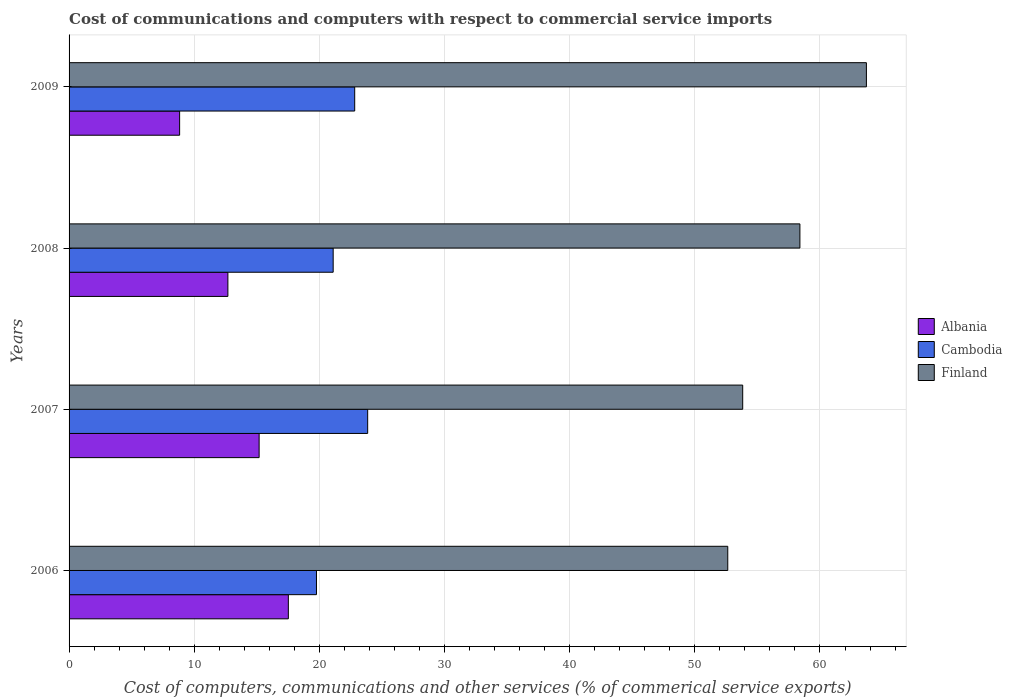How many different coloured bars are there?
Offer a very short reply. 3. How many groups of bars are there?
Offer a terse response. 4. Are the number of bars per tick equal to the number of legend labels?
Ensure brevity in your answer.  Yes. Are the number of bars on each tick of the Y-axis equal?
Your answer should be compact. Yes. What is the label of the 4th group of bars from the top?
Provide a short and direct response. 2006. What is the cost of communications and computers in Cambodia in 2008?
Give a very brief answer. 21.1. Across all years, what is the maximum cost of communications and computers in Albania?
Your answer should be very brief. 17.52. Across all years, what is the minimum cost of communications and computers in Cambodia?
Offer a terse response. 19.77. In which year was the cost of communications and computers in Cambodia minimum?
Offer a very short reply. 2006. What is the total cost of communications and computers in Finland in the graph?
Offer a very short reply. 228.56. What is the difference between the cost of communications and computers in Cambodia in 2006 and that in 2009?
Your answer should be very brief. -3.05. What is the difference between the cost of communications and computers in Cambodia in 2008 and the cost of communications and computers in Finland in 2007?
Make the answer very short. -32.72. What is the average cost of communications and computers in Cambodia per year?
Your response must be concise. 21.89. In the year 2009, what is the difference between the cost of communications and computers in Cambodia and cost of communications and computers in Albania?
Give a very brief answer. 13.99. What is the ratio of the cost of communications and computers in Finland in 2007 to that in 2008?
Your answer should be compact. 0.92. Is the cost of communications and computers in Cambodia in 2006 less than that in 2009?
Provide a succinct answer. Yes. What is the difference between the highest and the second highest cost of communications and computers in Finland?
Ensure brevity in your answer.  5.31. What is the difference between the highest and the lowest cost of communications and computers in Finland?
Provide a succinct answer. 11.08. What does the 2nd bar from the top in 2007 represents?
Your answer should be very brief. Cambodia. What does the 3rd bar from the bottom in 2008 represents?
Keep it short and to the point. Finland. Is it the case that in every year, the sum of the cost of communications and computers in Albania and cost of communications and computers in Finland is greater than the cost of communications and computers in Cambodia?
Offer a very short reply. Yes. How many bars are there?
Offer a terse response. 12. Are all the bars in the graph horizontal?
Your response must be concise. Yes. How many years are there in the graph?
Provide a succinct answer. 4. What is the difference between two consecutive major ticks on the X-axis?
Your response must be concise. 10. What is the title of the graph?
Give a very brief answer. Cost of communications and computers with respect to commercial service imports. Does "Fragile and conflict affected situations" appear as one of the legend labels in the graph?
Give a very brief answer. No. What is the label or title of the X-axis?
Offer a terse response. Cost of computers, communications and other services (% of commerical service exports). What is the label or title of the Y-axis?
Ensure brevity in your answer.  Years. What is the Cost of computers, communications and other services (% of commerical service exports) in Albania in 2006?
Provide a short and direct response. 17.52. What is the Cost of computers, communications and other services (% of commerical service exports) in Cambodia in 2006?
Offer a very short reply. 19.77. What is the Cost of computers, communications and other services (% of commerical service exports) of Finland in 2006?
Your answer should be very brief. 52.63. What is the Cost of computers, communications and other services (% of commerical service exports) in Albania in 2007?
Make the answer very short. 15.19. What is the Cost of computers, communications and other services (% of commerical service exports) of Cambodia in 2007?
Ensure brevity in your answer.  23.86. What is the Cost of computers, communications and other services (% of commerical service exports) in Finland in 2007?
Offer a very short reply. 53.83. What is the Cost of computers, communications and other services (% of commerical service exports) in Albania in 2008?
Provide a succinct answer. 12.69. What is the Cost of computers, communications and other services (% of commerical service exports) in Cambodia in 2008?
Your response must be concise. 21.1. What is the Cost of computers, communications and other services (% of commerical service exports) in Finland in 2008?
Give a very brief answer. 58.4. What is the Cost of computers, communications and other services (% of commerical service exports) in Albania in 2009?
Keep it short and to the point. 8.83. What is the Cost of computers, communications and other services (% of commerical service exports) in Cambodia in 2009?
Provide a succinct answer. 22.82. What is the Cost of computers, communications and other services (% of commerical service exports) of Finland in 2009?
Your answer should be very brief. 63.71. Across all years, what is the maximum Cost of computers, communications and other services (% of commerical service exports) in Albania?
Give a very brief answer. 17.52. Across all years, what is the maximum Cost of computers, communications and other services (% of commerical service exports) of Cambodia?
Keep it short and to the point. 23.86. Across all years, what is the maximum Cost of computers, communications and other services (% of commerical service exports) in Finland?
Your answer should be compact. 63.71. Across all years, what is the minimum Cost of computers, communications and other services (% of commerical service exports) of Albania?
Provide a short and direct response. 8.83. Across all years, what is the minimum Cost of computers, communications and other services (% of commerical service exports) in Cambodia?
Offer a very short reply. 19.77. Across all years, what is the minimum Cost of computers, communications and other services (% of commerical service exports) in Finland?
Your response must be concise. 52.63. What is the total Cost of computers, communications and other services (% of commerical service exports) in Albania in the graph?
Your response must be concise. 54.23. What is the total Cost of computers, communications and other services (% of commerical service exports) of Cambodia in the graph?
Ensure brevity in your answer.  87.55. What is the total Cost of computers, communications and other services (% of commerical service exports) of Finland in the graph?
Offer a terse response. 228.56. What is the difference between the Cost of computers, communications and other services (% of commerical service exports) of Albania in 2006 and that in 2007?
Ensure brevity in your answer.  2.33. What is the difference between the Cost of computers, communications and other services (% of commerical service exports) of Cambodia in 2006 and that in 2007?
Give a very brief answer. -4.09. What is the difference between the Cost of computers, communications and other services (% of commerical service exports) of Finland in 2006 and that in 2007?
Your response must be concise. -1.19. What is the difference between the Cost of computers, communications and other services (% of commerical service exports) in Albania in 2006 and that in 2008?
Keep it short and to the point. 4.83. What is the difference between the Cost of computers, communications and other services (% of commerical service exports) of Cambodia in 2006 and that in 2008?
Provide a succinct answer. -1.33. What is the difference between the Cost of computers, communications and other services (% of commerical service exports) in Finland in 2006 and that in 2008?
Ensure brevity in your answer.  -5.76. What is the difference between the Cost of computers, communications and other services (% of commerical service exports) of Albania in 2006 and that in 2009?
Your answer should be very brief. 8.69. What is the difference between the Cost of computers, communications and other services (% of commerical service exports) in Cambodia in 2006 and that in 2009?
Give a very brief answer. -3.05. What is the difference between the Cost of computers, communications and other services (% of commerical service exports) of Finland in 2006 and that in 2009?
Your response must be concise. -11.08. What is the difference between the Cost of computers, communications and other services (% of commerical service exports) in Albania in 2007 and that in 2008?
Keep it short and to the point. 2.5. What is the difference between the Cost of computers, communications and other services (% of commerical service exports) of Cambodia in 2007 and that in 2008?
Give a very brief answer. 2.76. What is the difference between the Cost of computers, communications and other services (% of commerical service exports) in Finland in 2007 and that in 2008?
Provide a succinct answer. -4.57. What is the difference between the Cost of computers, communications and other services (% of commerical service exports) in Albania in 2007 and that in 2009?
Provide a succinct answer. 6.35. What is the difference between the Cost of computers, communications and other services (% of commerical service exports) of Cambodia in 2007 and that in 2009?
Offer a terse response. 1.04. What is the difference between the Cost of computers, communications and other services (% of commerical service exports) in Finland in 2007 and that in 2009?
Your answer should be compact. -9.88. What is the difference between the Cost of computers, communications and other services (% of commerical service exports) in Albania in 2008 and that in 2009?
Keep it short and to the point. 3.86. What is the difference between the Cost of computers, communications and other services (% of commerical service exports) of Cambodia in 2008 and that in 2009?
Your response must be concise. -1.72. What is the difference between the Cost of computers, communications and other services (% of commerical service exports) in Finland in 2008 and that in 2009?
Ensure brevity in your answer.  -5.31. What is the difference between the Cost of computers, communications and other services (% of commerical service exports) in Albania in 2006 and the Cost of computers, communications and other services (% of commerical service exports) in Cambodia in 2007?
Keep it short and to the point. -6.34. What is the difference between the Cost of computers, communications and other services (% of commerical service exports) in Albania in 2006 and the Cost of computers, communications and other services (% of commerical service exports) in Finland in 2007?
Offer a very short reply. -36.31. What is the difference between the Cost of computers, communications and other services (% of commerical service exports) in Cambodia in 2006 and the Cost of computers, communications and other services (% of commerical service exports) in Finland in 2007?
Your response must be concise. -34.06. What is the difference between the Cost of computers, communications and other services (% of commerical service exports) of Albania in 2006 and the Cost of computers, communications and other services (% of commerical service exports) of Cambodia in 2008?
Your answer should be very brief. -3.58. What is the difference between the Cost of computers, communications and other services (% of commerical service exports) in Albania in 2006 and the Cost of computers, communications and other services (% of commerical service exports) in Finland in 2008?
Ensure brevity in your answer.  -40.88. What is the difference between the Cost of computers, communications and other services (% of commerical service exports) in Cambodia in 2006 and the Cost of computers, communications and other services (% of commerical service exports) in Finland in 2008?
Your answer should be very brief. -38.63. What is the difference between the Cost of computers, communications and other services (% of commerical service exports) of Albania in 2006 and the Cost of computers, communications and other services (% of commerical service exports) of Cambodia in 2009?
Offer a terse response. -5.3. What is the difference between the Cost of computers, communications and other services (% of commerical service exports) of Albania in 2006 and the Cost of computers, communications and other services (% of commerical service exports) of Finland in 2009?
Provide a succinct answer. -46.19. What is the difference between the Cost of computers, communications and other services (% of commerical service exports) in Cambodia in 2006 and the Cost of computers, communications and other services (% of commerical service exports) in Finland in 2009?
Your answer should be compact. -43.94. What is the difference between the Cost of computers, communications and other services (% of commerical service exports) in Albania in 2007 and the Cost of computers, communications and other services (% of commerical service exports) in Cambodia in 2008?
Ensure brevity in your answer.  -5.92. What is the difference between the Cost of computers, communications and other services (% of commerical service exports) of Albania in 2007 and the Cost of computers, communications and other services (% of commerical service exports) of Finland in 2008?
Give a very brief answer. -43.21. What is the difference between the Cost of computers, communications and other services (% of commerical service exports) of Cambodia in 2007 and the Cost of computers, communications and other services (% of commerical service exports) of Finland in 2008?
Your response must be concise. -34.54. What is the difference between the Cost of computers, communications and other services (% of commerical service exports) of Albania in 2007 and the Cost of computers, communications and other services (% of commerical service exports) of Cambodia in 2009?
Offer a very short reply. -7.64. What is the difference between the Cost of computers, communications and other services (% of commerical service exports) of Albania in 2007 and the Cost of computers, communications and other services (% of commerical service exports) of Finland in 2009?
Ensure brevity in your answer.  -48.52. What is the difference between the Cost of computers, communications and other services (% of commerical service exports) in Cambodia in 2007 and the Cost of computers, communications and other services (% of commerical service exports) in Finland in 2009?
Keep it short and to the point. -39.85. What is the difference between the Cost of computers, communications and other services (% of commerical service exports) of Albania in 2008 and the Cost of computers, communications and other services (% of commerical service exports) of Cambodia in 2009?
Offer a very short reply. -10.13. What is the difference between the Cost of computers, communications and other services (% of commerical service exports) of Albania in 2008 and the Cost of computers, communications and other services (% of commerical service exports) of Finland in 2009?
Your answer should be compact. -51.02. What is the difference between the Cost of computers, communications and other services (% of commerical service exports) in Cambodia in 2008 and the Cost of computers, communications and other services (% of commerical service exports) in Finland in 2009?
Make the answer very short. -42.61. What is the average Cost of computers, communications and other services (% of commerical service exports) of Albania per year?
Make the answer very short. 13.56. What is the average Cost of computers, communications and other services (% of commerical service exports) of Cambodia per year?
Make the answer very short. 21.89. What is the average Cost of computers, communications and other services (% of commerical service exports) in Finland per year?
Provide a succinct answer. 57.14. In the year 2006, what is the difference between the Cost of computers, communications and other services (% of commerical service exports) in Albania and Cost of computers, communications and other services (% of commerical service exports) in Cambodia?
Give a very brief answer. -2.25. In the year 2006, what is the difference between the Cost of computers, communications and other services (% of commerical service exports) in Albania and Cost of computers, communications and other services (% of commerical service exports) in Finland?
Provide a succinct answer. -35.11. In the year 2006, what is the difference between the Cost of computers, communications and other services (% of commerical service exports) in Cambodia and Cost of computers, communications and other services (% of commerical service exports) in Finland?
Provide a succinct answer. -32.86. In the year 2007, what is the difference between the Cost of computers, communications and other services (% of commerical service exports) in Albania and Cost of computers, communications and other services (% of commerical service exports) in Cambodia?
Your response must be concise. -8.67. In the year 2007, what is the difference between the Cost of computers, communications and other services (% of commerical service exports) of Albania and Cost of computers, communications and other services (% of commerical service exports) of Finland?
Provide a short and direct response. -38.64. In the year 2007, what is the difference between the Cost of computers, communications and other services (% of commerical service exports) of Cambodia and Cost of computers, communications and other services (% of commerical service exports) of Finland?
Provide a short and direct response. -29.97. In the year 2008, what is the difference between the Cost of computers, communications and other services (% of commerical service exports) of Albania and Cost of computers, communications and other services (% of commerical service exports) of Cambodia?
Your response must be concise. -8.41. In the year 2008, what is the difference between the Cost of computers, communications and other services (% of commerical service exports) of Albania and Cost of computers, communications and other services (% of commerical service exports) of Finland?
Make the answer very short. -45.71. In the year 2008, what is the difference between the Cost of computers, communications and other services (% of commerical service exports) in Cambodia and Cost of computers, communications and other services (% of commerical service exports) in Finland?
Offer a very short reply. -37.29. In the year 2009, what is the difference between the Cost of computers, communications and other services (% of commerical service exports) of Albania and Cost of computers, communications and other services (% of commerical service exports) of Cambodia?
Make the answer very short. -13.99. In the year 2009, what is the difference between the Cost of computers, communications and other services (% of commerical service exports) of Albania and Cost of computers, communications and other services (% of commerical service exports) of Finland?
Ensure brevity in your answer.  -54.88. In the year 2009, what is the difference between the Cost of computers, communications and other services (% of commerical service exports) in Cambodia and Cost of computers, communications and other services (% of commerical service exports) in Finland?
Provide a succinct answer. -40.89. What is the ratio of the Cost of computers, communications and other services (% of commerical service exports) in Albania in 2006 to that in 2007?
Offer a terse response. 1.15. What is the ratio of the Cost of computers, communications and other services (% of commerical service exports) of Cambodia in 2006 to that in 2007?
Keep it short and to the point. 0.83. What is the ratio of the Cost of computers, communications and other services (% of commerical service exports) in Finland in 2006 to that in 2007?
Ensure brevity in your answer.  0.98. What is the ratio of the Cost of computers, communications and other services (% of commerical service exports) of Albania in 2006 to that in 2008?
Your response must be concise. 1.38. What is the ratio of the Cost of computers, communications and other services (% of commerical service exports) in Cambodia in 2006 to that in 2008?
Give a very brief answer. 0.94. What is the ratio of the Cost of computers, communications and other services (% of commerical service exports) in Finland in 2006 to that in 2008?
Keep it short and to the point. 0.9. What is the ratio of the Cost of computers, communications and other services (% of commerical service exports) in Albania in 2006 to that in 2009?
Your response must be concise. 1.98. What is the ratio of the Cost of computers, communications and other services (% of commerical service exports) in Cambodia in 2006 to that in 2009?
Make the answer very short. 0.87. What is the ratio of the Cost of computers, communications and other services (% of commerical service exports) in Finland in 2006 to that in 2009?
Your answer should be compact. 0.83. What is the ratio of the Cost of computers, communications and other services (% of commerical service exports) in Albania in 2007 to that in 2008?
Keep it short and to the point. 1.2. What is the ratio of the Cost of computers, communications and other services (% of commerical service exports) in Cambodia in 2007 to that in 2008?
Give a very brief answer. 1.13. What is the ratio of the Cost of computers, communications and other services (% of commerical service exports) in Finland in 2007 to that in 2008?
Give a very brief answer. 0.92. What is the ratio of the Cost of computers, communications and other services (% of commerical service exports) of Albania in 2007 to that in 2009?
Provide a succinct answer. 1.72. What is the ratio of the Cost of computers, communications and other services (% of commerical service exports) of Cambodia in 2007 to that in 2009?
Ensure brevity in your answer.  1.05. What is the ratio of the Cost of computers, communications and other services (% of commerical service exports) in Finland in 2007 to that in 2009?
Offer a terse response. 0.84. What is the ratio of the Cost of computers, communications and other services (% of commerical service exports) in Albania in 2008 to that in 2009?
Your answer should be very brief. 1.44. What is the ratio of the Cost of computers, communications and other services (% of commerical service exports) of Cambodia in 2008 to that in 2009?
Offer a very short reply. 0.92. What is the ratio of the Cost of computers, communications and other services (% of commerical service exports) in Finland in 2008 to that in 2009?
Ensure brevity in your answer.  0.92. What is the difference between the highest and the second highest Cost of computers, communications and other services (% of commerical service exports) in Albania?
Make the answer very short. 2.33. What is the difference between the highest and the second highest Cost of computers, communications and other services (% of commerical service exports) in Cambodia?
Offer a very short reply. 1.04. What is the difference between the highest and the second highest Cost of computers, communications and other services (% of commerical service exports) of Finland?
Offer a terse response. 5.31. What is the difference between the highest and the lowest Cost of computers, communications and other services (% of commerical service exports) of Albania?
Your response must be concise. 8.69. What is the difference between the highest and the lowest Cost of computers, communications and other services (% of commerical service exports) in Cambodia?
Keep it short and to the point. 4.09. What is the difference between the highest and the lowest Cost of computers, communications and other services (% of commerical service exports) in Finland?
Your answer should be very brief. 11.08. 